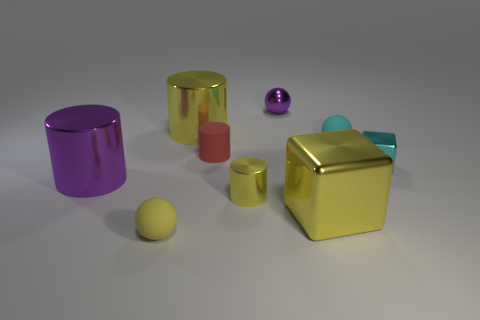Subtract all small cyan spheres. How many spheres are left? 2 Subtract all purple spheres. How many spheres are left? 2 Add 1 tiny red cylinders. How many objects exist? 10 Subtract 1 cubes. How many cubes are left? 1 Subtract all purple blocks. Subtract all red cylinders. How many blocks are left? 2 Subtract all brown balls. How many red cylinders are left? 1 Subtract all tiny metallic cylinders. Subtract all purple metal cylinders. How many objects are left? 7 Add 5 small yellow metallic objects. How many small yellow metallic objects are left? 6 Add 8 brown shiny cubes. How many brown shiny cubes exist? 8 Subtract 0 gray spheres. How many objects are left? 9 